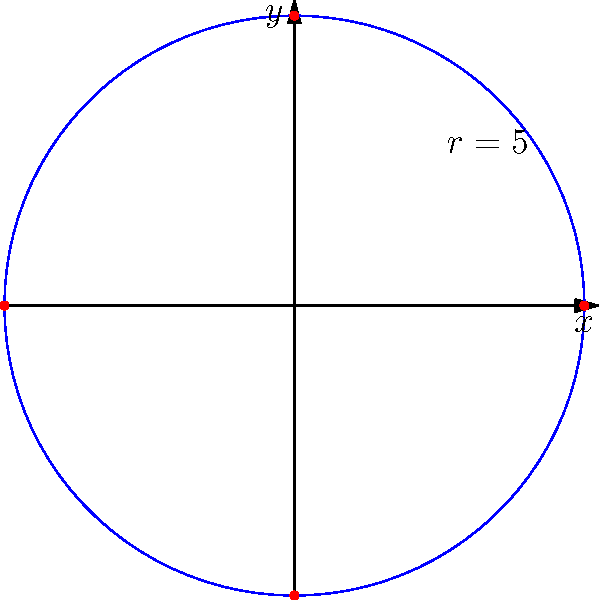In a simplified model of Stonehenge, the outer circle of stones can be represented by the polar equation $r = 5$. If an archaeologist wants to find the Cartesian coordinates of the stones located at $\theta = 0°, 90°, 180°,$ and $270°$, what would be the coordinates of these four points? To solve this problem, we need to convert from polar coordinates $(r,\theta)$ to Cartesian coordinates $(x,y)$ using the following formulas:

1) $x = r \cos(\theta)$
2) $y = r \sin(\theta)$

Given: $r = 5$ for all points.

For $\theta = 0°$:
$x = 5 \cos(0°) = 5$
$y = 5 \sin(0°) = 0$
Coordinates: $(5,0)$

For $\theta = 90°$:
$x = 5 \cos(90°) = 0$
$y = 5 \sin(90°) = 5$
Coordinates: $(0,5)$

For $\theta = 180°$:
$x = 5 \cos(180°) = -5$
$y = 5 \sin(180°) = 0$
Coordinates: $(-5,0)$

For $\theta = 270°$:
$x = 5 \cos(270°) = 0$
$y = 5 \sin(270°) = -5$
Coordinates: $(0,-5)$

These four points form a square with side length 10, centered at the origin.
Answer: $(5,0)$, $(0,5)$, $(-5,0)$, $(0,-5)$ 